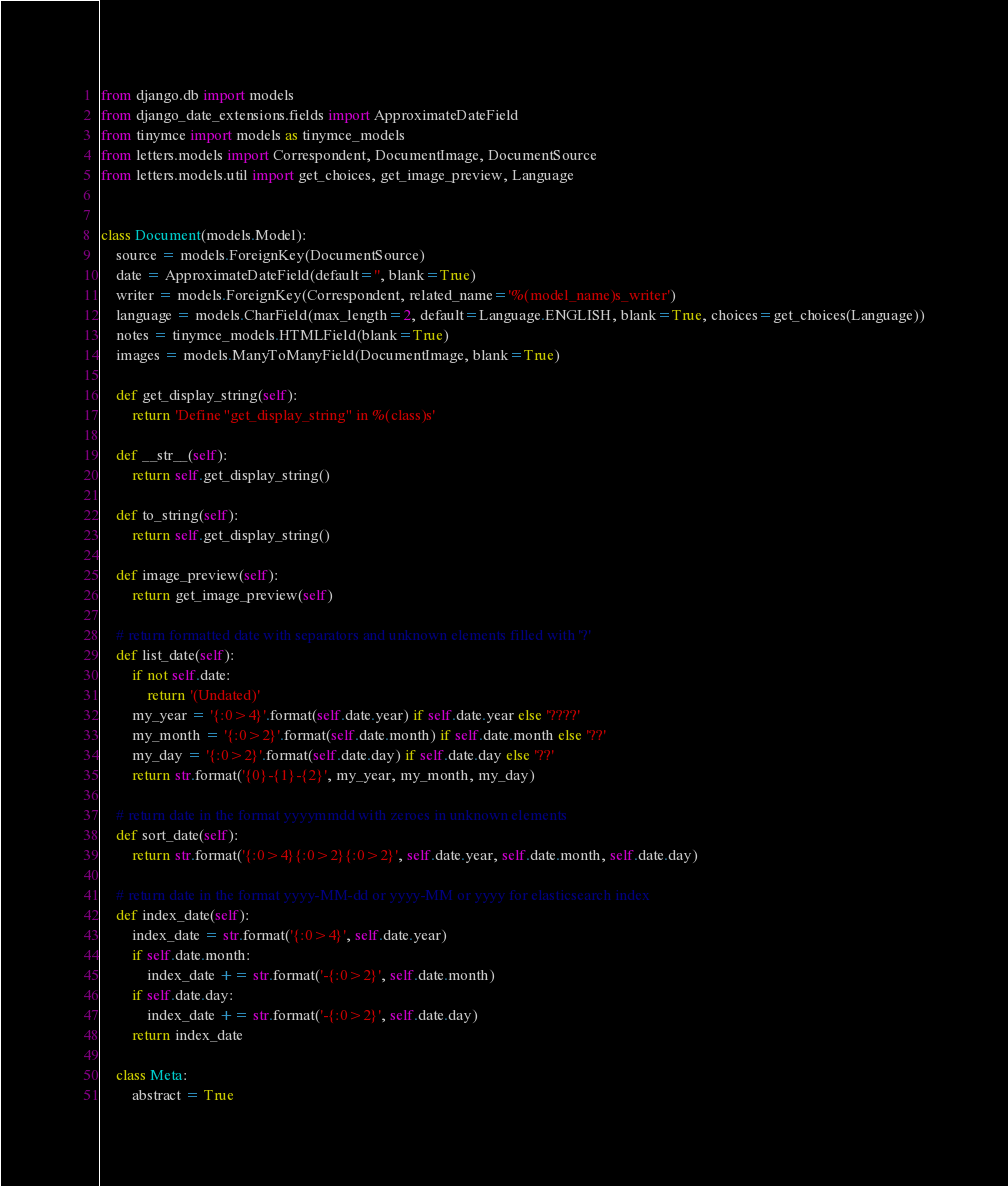<code> <loc_0><loc_0><loc_500><loc_500><_Python_>from django.db import models
from django_date_extensions.fields import ApproximateDateField
from tinymce import models as tinymce_models
from letters.models import Correspondent, DocumentImage, DocumentSource
from letters.models.util import get_choices, get_image_preview, Language


class Document(models.Model):
    source = models.ForeignKey(DocumentSource)
    date = ApproximateDateField(default='', blank=True)
    writer = models.ForeignKey(Correspondent, related_name='%(model_name)s_writer')
    language = models.CharField(max_length=2, default=Language.ENGLISH, blank=True, choices=get_choices(Language))
    notes = tinymce_models.HTMLField(blank=True)
    images = models.ManyToManyField(DocumentImage, blank=True)

    def get_display_string(self):
        return 'Define "get_display_string" in %(class)s'

    def __str__(self):
        return self.get_display_string()

    def to_string(self):
        return self.get_display_string()

    def image_preview(self):
        return get_image_preview(self)

    # return formatted date with separators and unknown elements filled with '?'
    def list_date(self):
        if not self.date:
            return '(Undated)'
        my_year = '{:0>4}'.format(self.date.year) if self.date.year else '????'
        my_month = '{:0>2}'.format(self.date.month) if self.date.month else '??'
        my_day = '{:0>2}'.format(self.date.day) if self.date.day else '??'
        return str.format('{0}-{1}-{2}', my_year, my_month, my_day)

    # return date in the format yyyymmdd with zeroes in unknown elements
    def sort_date(self):
        return str.format('{:0>4}{:0>2}{:0>2}', self.date.year, self.date.month, self.date.day)

    # return date in the format yyyy-MM-dd or yyyy-MM or yyyy for elasticsearch index
    def index_date(self):
        index_date = str.format('{:0>4}', self.date.year)
        if self.date.month:
            index_date += str.format('-{:0>2}', self.date.month)
        if self.date.day:
            index_date += str.format('-{:0>2}', self.date.day)
        return index_date

    class Meta:
        abstract = True

</code> 